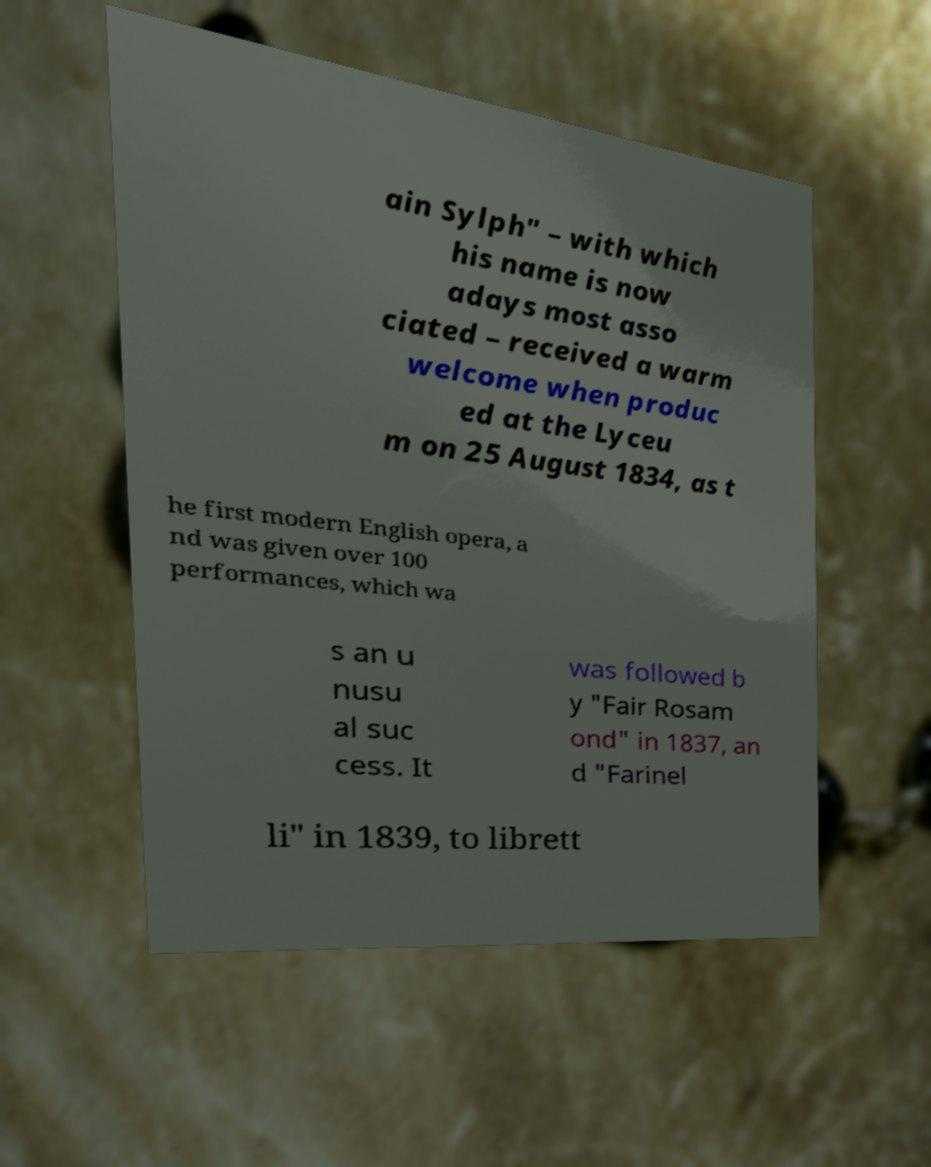Please read and relay the text visible in this image. What does it say? ain Sylph" – with which his name is now adays most asso ciated – received a warm welcome when produc ed at the Lyceu m on 25 August 1834, as t he first modern English opera, a nd was given over 100 performances, which wa s an u nusu al suc cess. It was followed b y "Fair Rosam ond" in 1837, an d "Farinel li" in 1839, to librett 